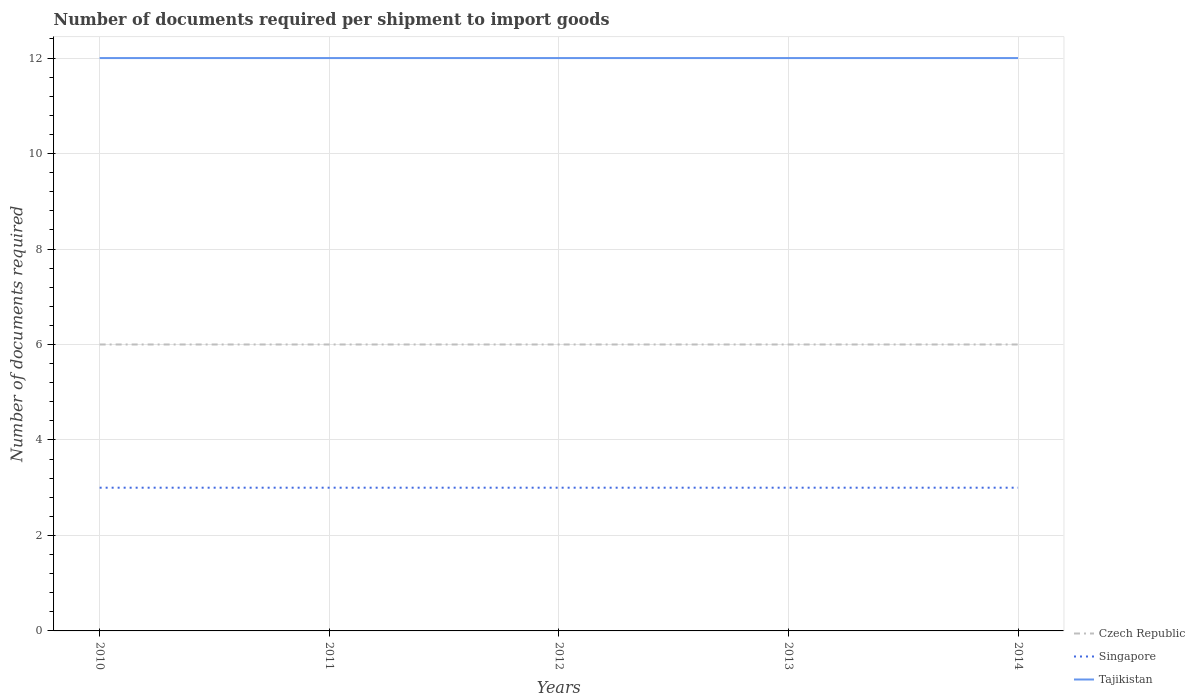How many different coloured lines are there?
Ensure brevity in your answer.  3. Across all years, what is the maximum number of documents required per shipment to import goods in Singapore?
Give a very brief answer. 3. In which year was the number of documents required per shipment to import goods in Tajikistan maximum?
Keep it short and to the point. 2010. What is the difference between the highest and the second highest number of documents required per shipment to import goods in Czech Republic?
Ensure brevity in your answer.  0. Is the number of documents required per shipment to import goods in Singapore strictly greater than the number of documents required per shipment to import goods in Czech Republic over the years?
Your answer should be very brief. Yes. How many lines are there?
Your answer should be very brief. 3. What is the difference between two consecutive major ticks on the Y-axis?
Ensure brevity in your answer.  2. Are the values on the major ticks of Y-axis written in scientific E-notation?
Make the answer very short. No. Does the graph contain any zero values?
Your answer should be very brief. No. Does the graph contain grids?
Keep it short and to the point. Yes. How are the legend labels stacked?
Offer a terse response. Vertical. What is the title of the graph?
Provide a succinct answer. Number of documents required per shipment to import goods. What is the label or title of the Y-axis?
Provide a short and direct response. Number of documents required. What is the Number of documents required of Tajikistan in 2010?
Your answer should be compact. 12. What is the Number of documents required of Czech Republic in 2013?
Make the answer very short. 6. Across all years, what is the maximum Number of documents required in Czech Republic?
Offer a very short reply. 6. Across all years, what is the maximum Number of documents required in Singapore?
Provide a succinct answer. 3. What is the total Number of documents required in Czech Republic in the graph?
Offer a terse response. 30. What is the total Number of documents required of Singapore in the graph?
Provide a short and direct response. 15. What is the total Number of documents required in Tajikistan in the graph?
Provide a succinct answer. 60. What is the difference between the Number of documents required of Czech Republic in 2010 and that in 2011?
Your response must be concise. 0. What is the difference between the Number of documents required of Czech Republic in 2010 and that in 2012?
Make the answer very short. 0. What is the difference between the Number of documents required of Singapore in 2010 and that in 2012?
Your answer should be very brief. 0. What is the difference between the Number of documents required in Singapore in 2010 and that in 2013?
Ensure brevity in your answer.  0. What is the difference between the Number of documents required in Czech Republic in 2010 and that in 2014?
Your answer should be very brief. 0. What is the difference between the Number of documents required in Singapore in 2010 and that in 2014?
Provide a short and direct response. 0. What is the difference between the Number of documents required of Singapore in 2011 and that in 2012?
Make the answer very short. 0. What is the difference between the Number of documents required of Czech Republic in 2011 and that in 2014?
Your answer should be compact. 0. What is the difference between the Number of documents required in Czech Republic in 2012 and that in 2013?
Offer a terse response. 0. What is the difference between the Number of documents required of Singapore in 2012 and that in 2013?
Offer a very short reply. 0. What is the difference between the Number of documents required in Tajikistan in 2012 and that in 2013?
Ensure brevity in your answer.  0. What is the difference between the Number of documents required of Czech Republic in 2012 and that in 2014?
Provide a succinct answer. 0. What is the difference between the Number of documents required in Singapore in 2012 and that in 2014?
Your answer should be very brief. 0. What is the difference between the Number of documents required of Tajikistan in 2012 and that in 2014?
Make the answer very short. 0. What is the difference between the Number of documents required of Czech Republic in 2010 and the Number of documents required of Singapore in 2011?
Your response must be concise. 3. What is the difference between the Number of documents required in Czech Republic in 2010 and the Number of documents required in Tajikistan in 2011?
Offer a terse response. -6. What is the difference between the Number of documents required in Singapore in 2010 and the Number of documents required in Tajikistan in 2011?
Provide a succinct answer. -9. What is the difference between the Number of documents required of Czech Republic in 2010 and the Number of documents required of Singapore in 2012?
Your answer should be compact. 3. What is the difference between the Number of documents required in Czech Republic in 2010 and the Number of documents required in Tajikistan in 2012?
Provide a short and direct response. -6. What is the difference between the Number of documents required in Czech Republic in 2010 and the Number of documents required in Singapore in 2013?
Provide a succinct answer. 3. What is the difference between the Number of documents required of Czech Republic in 2010 and the Number of documents required of Tajikistan in 2013?
Offer a terse response. -6. What is the difference between the Number of documents required of Czech Republic in 2010 and the Number of documents required of Singapore in 2014?
Your answer should be very brief. 3. What is the difference between the Number of documents required in Singapore in 2011 and the Number of documents required in Tajikistan in 2012?
Provide a short and direct response. -9. What is the difference between the Number of documents required in Czech Republic in 2011 and the Number of documents required in Tajikistan in 2013?
Offer a very short reply. -6. What is the difference between the Number of documents required of Singapore in 2011 and the Number of documents required of Tajikistan in 2013?
Offer a very short reply. -9. What is the difference between the Number of documents required in Czech Republic in 2011 and the Number of documents required in Singapore in 2014?
Provide a succinct answer. 3. What is the difference between the Number of documents required of Singapore in 2011 and the Number of documents required of Tajikistan in 2014?
Give a very brief answer. -9. What is the difference between the Number of documents required of Czech Republic in 2012 and the Number of documents required of Tajikistan in 2013?
Make the answer very short. -6. What is the difference between the Number of documents required of Singapore in 2012 and the Number of documents required of Tajikistan in 2013?
Keep it short and to the point. -9. What is the difference between the Number of documents required of Singapore in 2012 and the Number of documents required of Tajikistan in 2014?
Your answer should be compact. -9. What is the difference between the Number of documents required of Czech Republic in 2013 and the Number of documents required of Singapore in 2014?
Provide a short and direct response. 3. What is the difference between the Number of documents required of Czech Republic in 2013 and the Number of documents required of Tajikistan in 2014?
Make the answer very short. -6. What is the difference between the Number of documents required of Singapore in 2013 and the Number of documents required of Tajikistan in 2014?
Make the answer very short. -9. What is the average Number of documents required in Czech Republic per year?
Your answer should be very brief. 6. What is the average Number of documents required in Singapore per year?
Ensure brevity in your answer.  3. In the year 2010, what is the difference between the Number of documents required of Czech Republic and Number of documents required of Singapore?
Give a very brief answer. 3. In the year 2010, what is the difference between the Number of documents required of Czech Republic and Number of documents required of Tajikistan?
Make the answer very short. -6. In the year 2011, what is the difference between the Number of documents required of Czech Republic and Number of documents required of Tajikistan?
Keep it short and to the point. -6. In the year 2011, what is the difference between the Number of documents required of Singapore and Number of documents required of Tajikistan?
Give a very brief answer. -9. In the year 2013, what is the difference between the Number of documents required in Czech Republic and Number of documents required in Singapore?
Keep it short and to the point. 3. In the year 2013, what is the difference between the Number of documents required of Czech Republic and Number of documents required of Tajikistan?
Your response must be concise. -6. In the year 2014, what is the difference between the Number of documents required in Czech Republic and Number of documents required in Singapore?
Your answer should be compact. 3. In the year 2014, what is the difference between the Number of documents required of Czech Republic and Number of documents required of Tajikistan?
Provide a short and direct response. -6. In the year 2014, what is the difference between the Number of documents required of Singapore and Number of documents required of Tajikistan?
Provide a short and direct response. -9. What is the ratio of the Number of documents required of Czech Republic in 2010 to that in 2011?
Keep it short and to the point. 1. What is the ratio of the Number of documents required in Czech Republic in 2010 to that in 2012?
Keep it short and to the point. 1. What is the ratio of the Number of documents required of Czech Republic in 2010 to that in 2013?
Your answer should be compact. 1. What is the ratio of the Number of documents required in Singapore in 2010 to that in 2014?
Ensure brevity in your answer.  1. What is the ratio of the Number of documents required in Czech Republic in 2011 to that in 2014?
Keep it short and to the point. 1. What is the ratio of the Number of documents required in Singapore in 2011 to that in 2014?
Make the answer very short. 1. What is the ratio of the Number of documents required in Czech Republic in 2012 to that in 2013?
Make the answer very short. 1. What is the ratio of the Number of documents required of Singapore in 2012 to that in 2013?
Your response must be concise. 1. What is the ratio of the Number of documents required in Tajikistan in 2012 to that in 2013?
Give a very brief answer. 1. What is the ratio of the Number of documents required in Tajikistan in 2012 to that in 2014?
Ensure brevity in your answer.  1. What is the ratio of the Number of documents required in Czech Republic in 2013 to that in 2014?
Keep it short and to the point. 1. What is the ratio of the Number of documents required in Singapore in 2013 to that in 2014?
Give a very brief answer. 1. What is the ratio of the Number of documents required of Tajikistan in 2013 to that in 2014?
Make the answer very short. 1. What is the difference between the highest and the lowest Number of documents required of Czech Republic?
Make the answer very short. 0. What is the difference between the highest and the lowest Number of documents required of Tajikistan?
Your response must be concise. 0. 